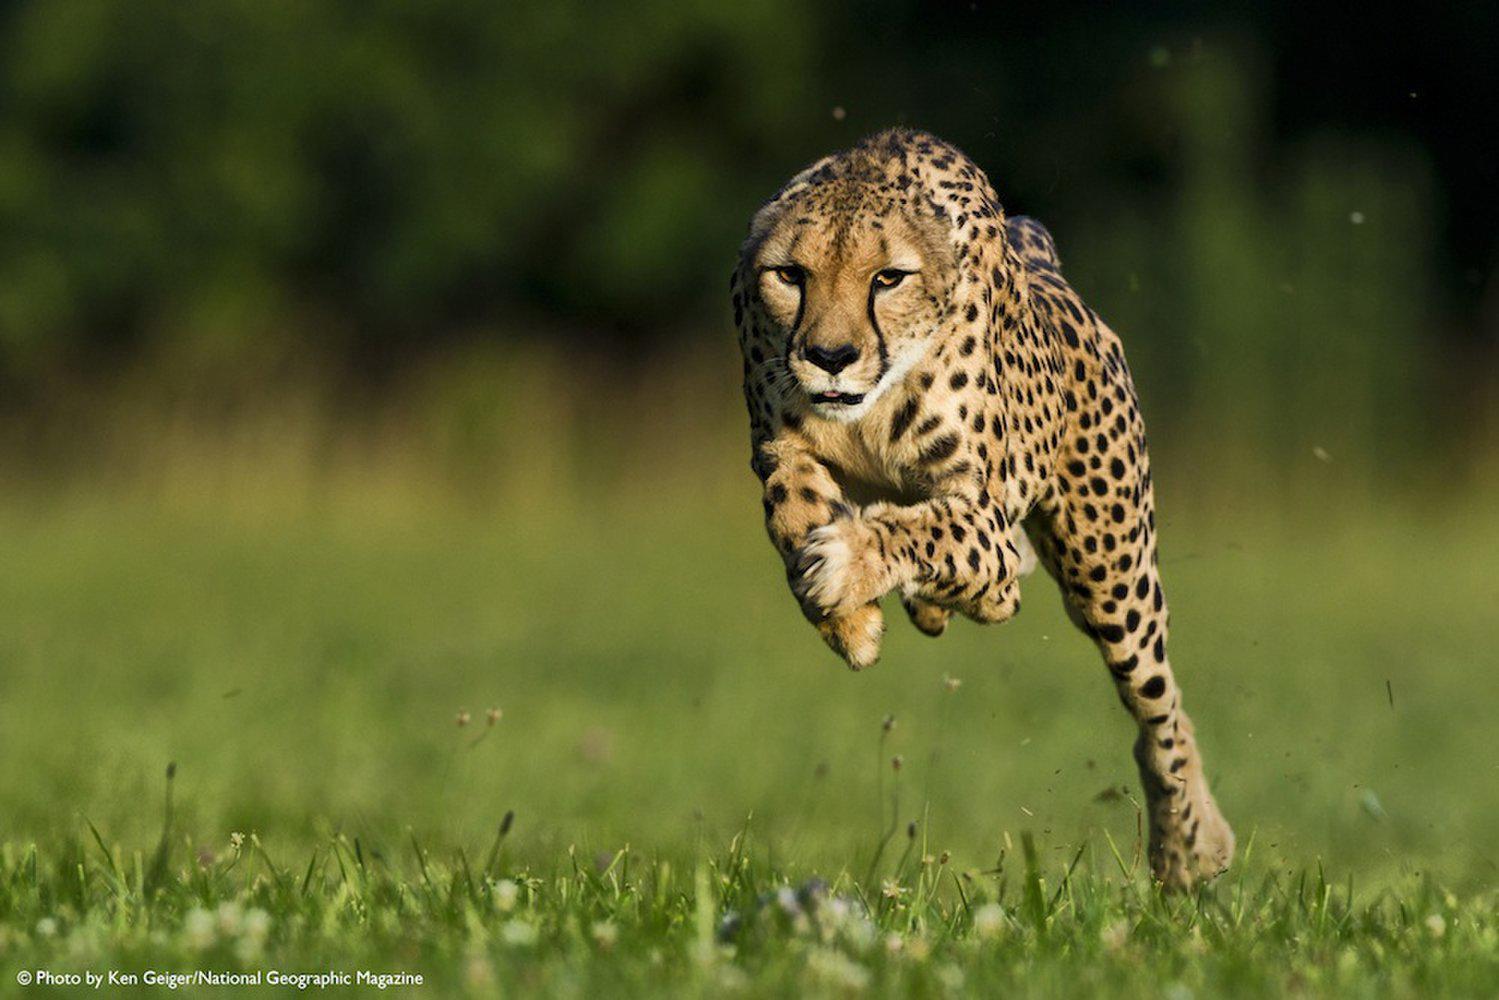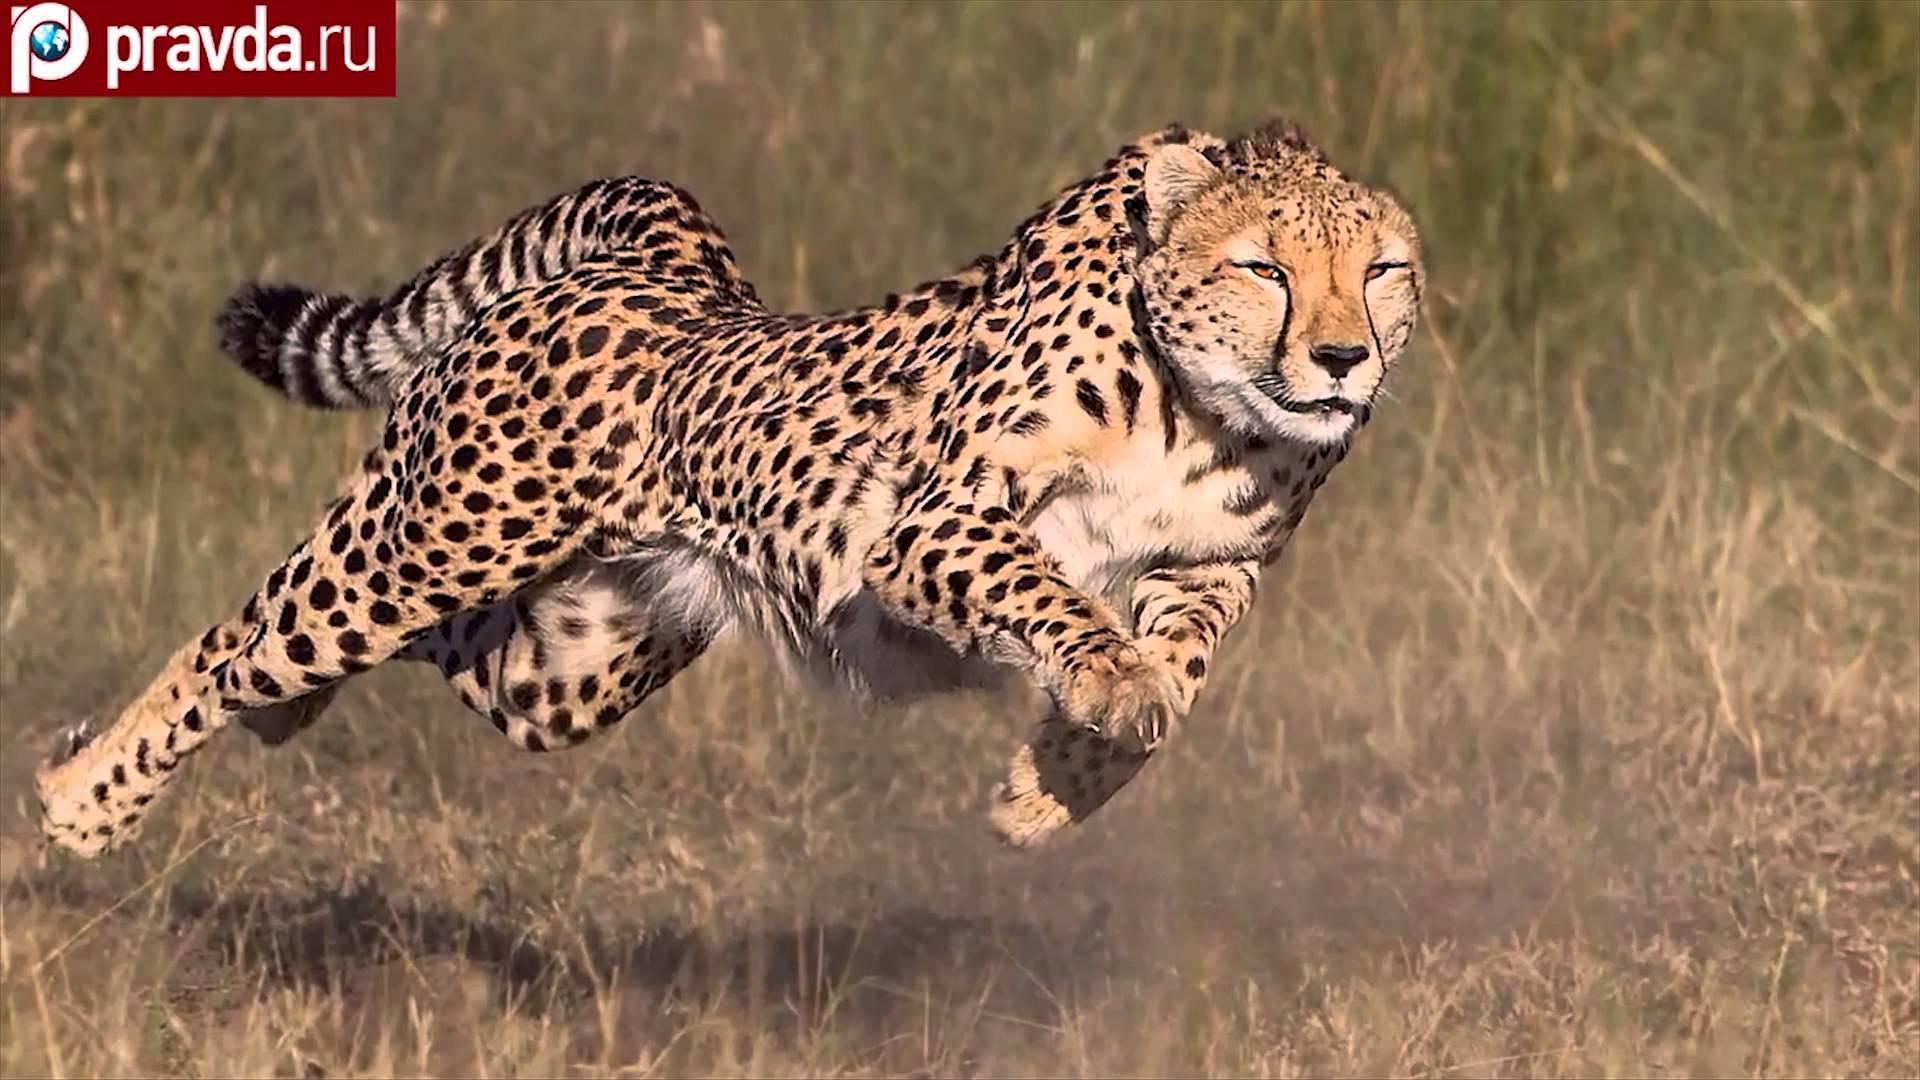The first image is the image on the left, the second image is the image on the right. Examine the images to the left and right. Is the description "All the cheetahs are running the same direction, to the right." accurate? Answer yes or no. No. 